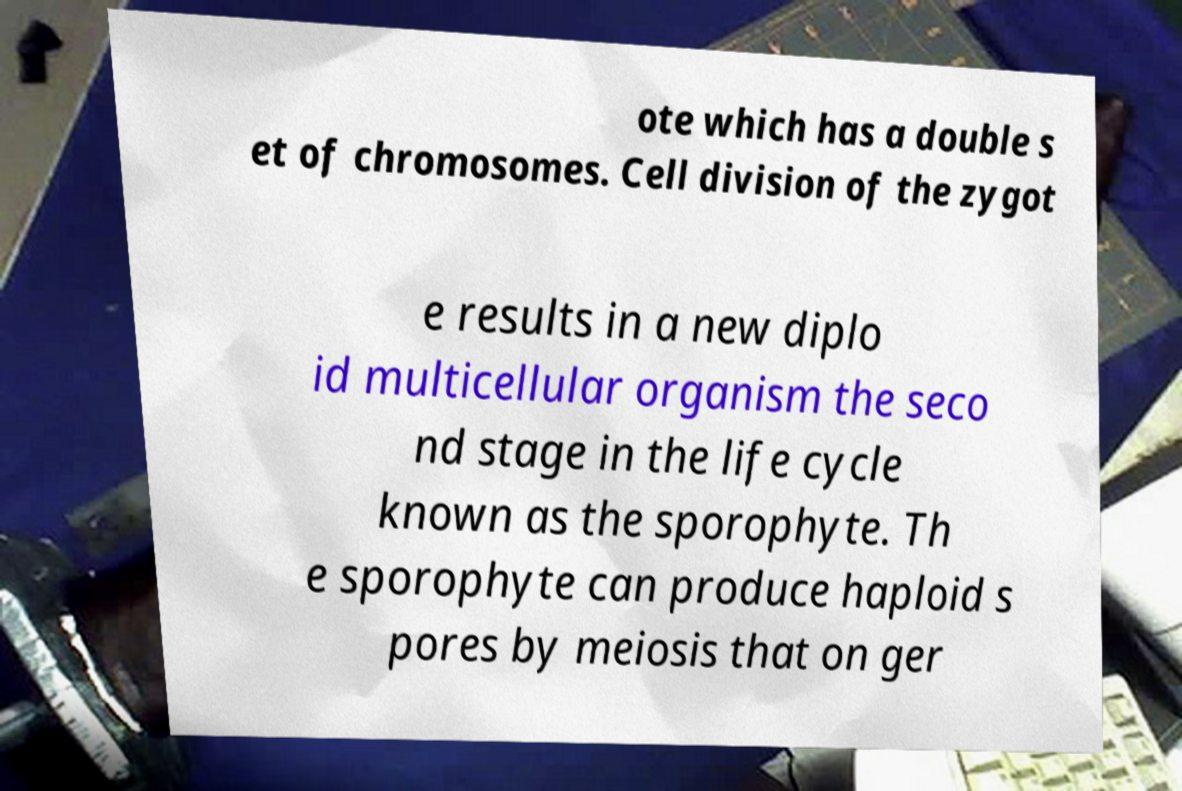Please read and relay the text visible in this image. What does it say? ote which has a double s et of chromosomes. Cell division of the zygot e results in a new diplo id multicellular organism the seco nd stage in the life cycle known as the sporophyte. Th e sporophyte can produce haploid s pores by meiosis that on ger 